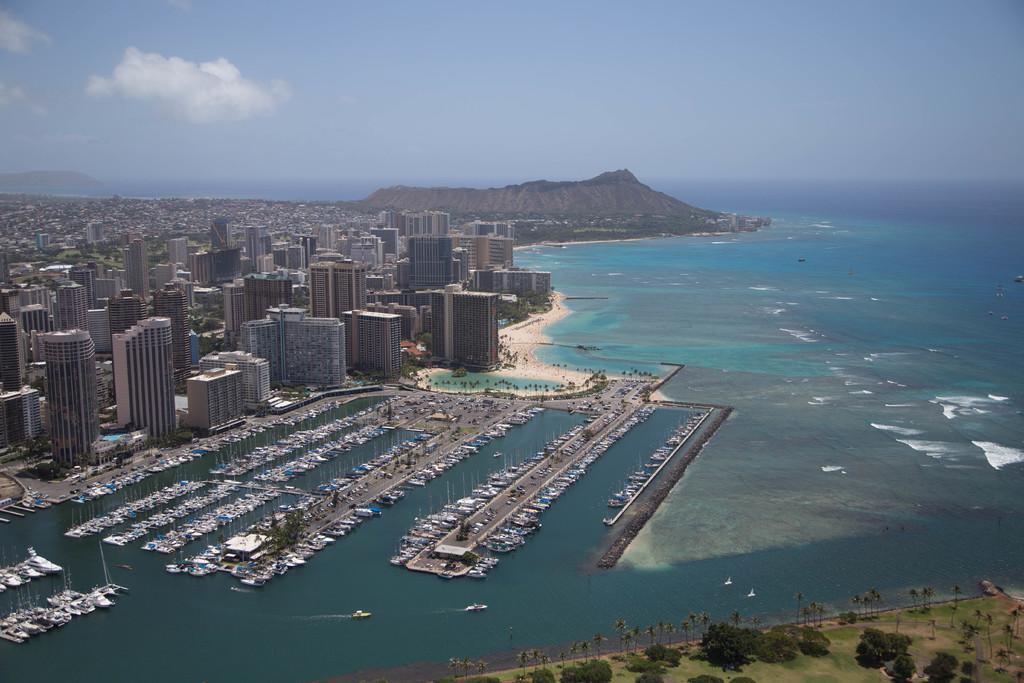Please provide a concise description of this image. In this picture I can see buildings, water and a mountain. In the background I can see the sky. Here I can see trees and boats on the water. 